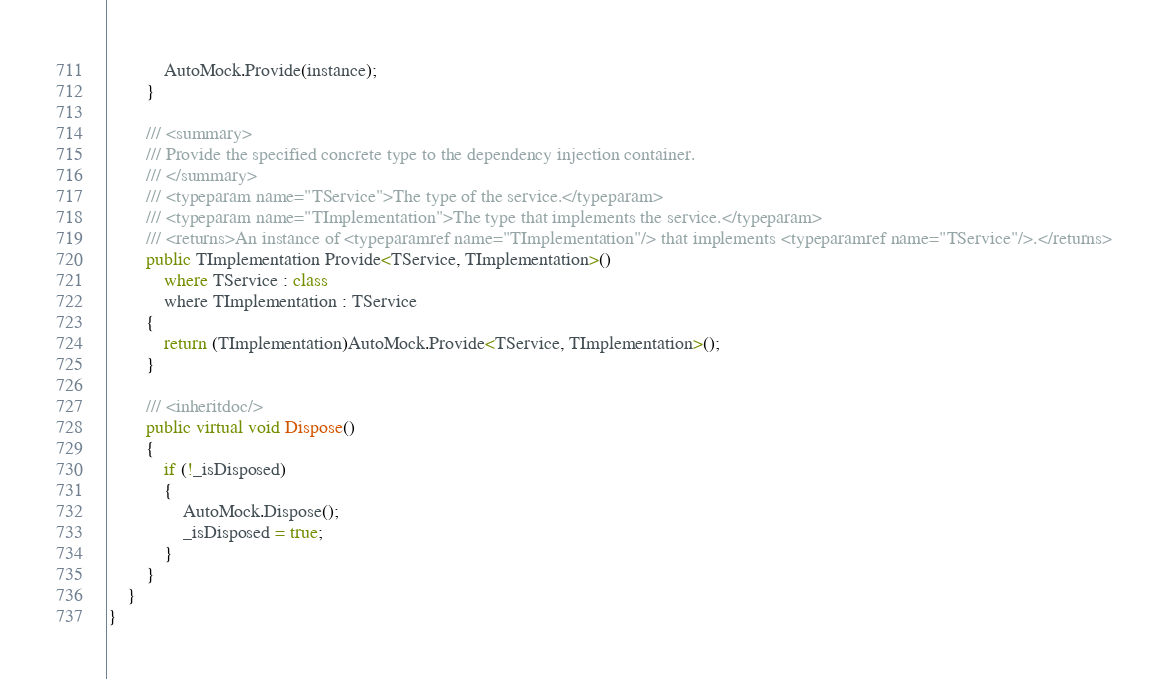Convert code to text. <code><loc_0><loc_0><loc_500><loc_500><_C#_>
            AutoMock.Provide(instance);
        }

        /// <summary>
        /// Provide the specified concrete type to the dependency injection container.
        /// </summary>
        /// <typeparam name="TService">The type of the service.</typeparam>
        /// <typeparam name="TImplementation">The type that implements the service.</typeparam>
        /// <returns>An instance of <typeparamref name="TImplementation"/> that implements <typeparamref name="TService"/>.</returns>
        public TImplementation Provide<TService, TImplementation>()
            where TService : class
            where TImplementation : TService
        {
            return (TImplementation)AutoMock.Provide<TService, TImplementation>();
        }

        /// <inheritdoc/>
        public virtual void Dispose()
        {
            if (!_isDisposed)
            {
                AutoMock.Dispose();
                _isDisposed = true;
            }
        }
    }
}
</code> 